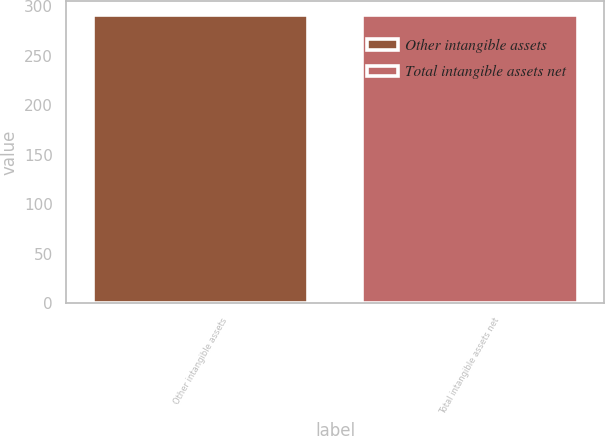<chart> <loc_0><loc_0><loc_500><loc_500><bar_chart><fcel>Other intangible assets<fcel>Total intangible assets net<nl><fcel>291<fcel>291.1<nl></chart> 